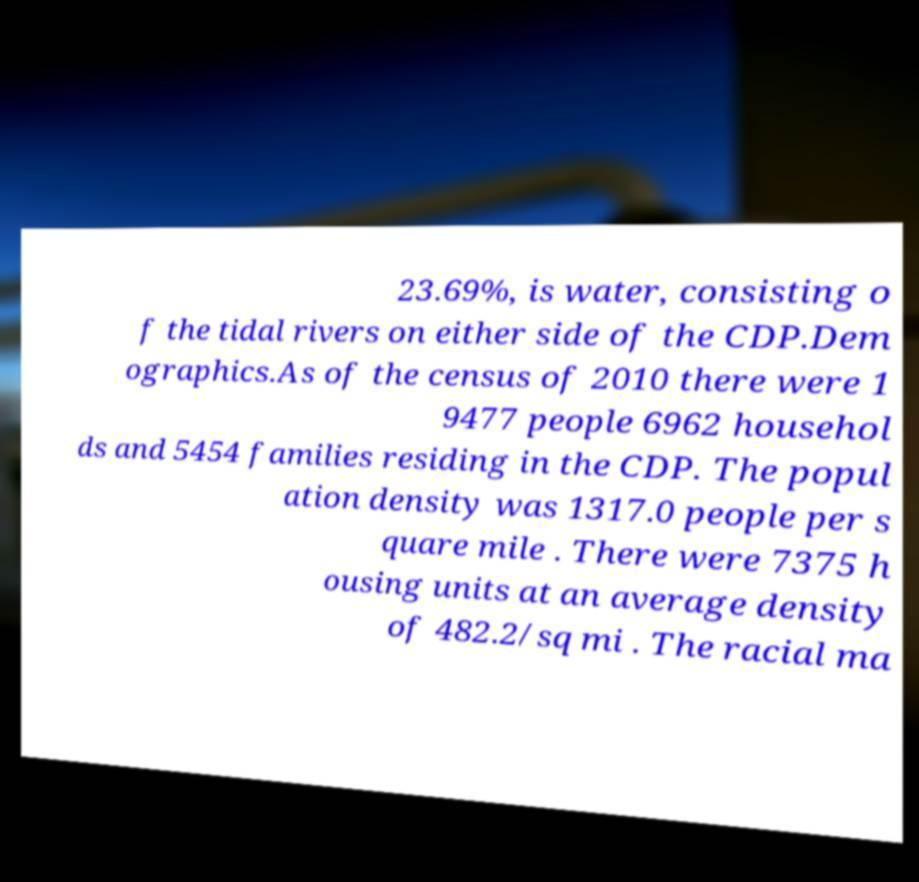Please identify and transcribe the text found in this image. 23.69%, is water, consisting o f the tidal rivers on either side of the CDP.Dem ographics.As of the census of 2010 there were 1 9477 people 6962 househol ds and 5454 families residing in the CDP. The popul ation density was 1317.0 people per s quare mile . There were 7375 h ousing units at an average density of 482.2/sq mi . The racial ma 